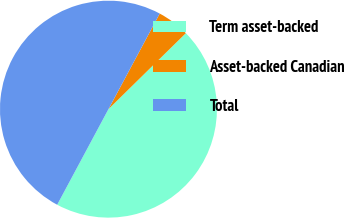Convert chart. <chart><loc_0><loc_0><loc_500><loc_500><pie_chart><fcel>Term asset-backed<fcel>Asset-backed Canadian<fcel>Total<nl><fcel>45.19%<fcel>4.81%<fcel>50.0%<nl></chart> 